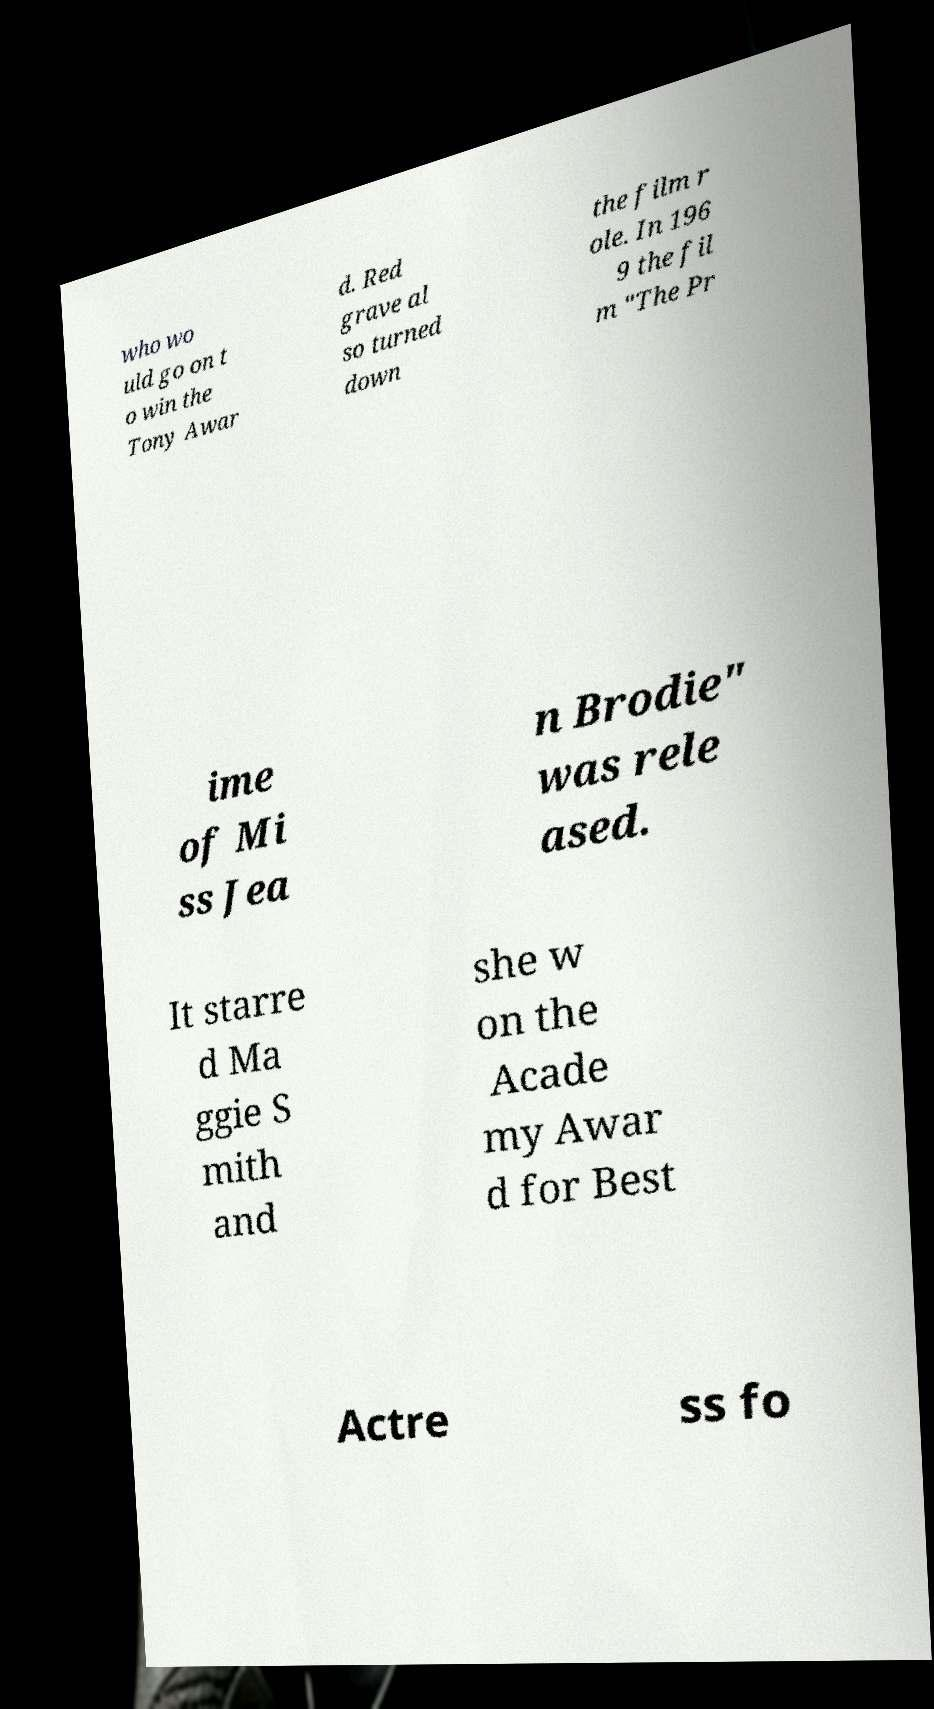Could you assist in decoding the text presented in this image and type it out clearly? who wo uld go on t o win the Tony Awar d. Red grave al so turned down the film r ole. In 196 9 the fil m "The Pr ime of Mi ss Jea n Brodie" was rele ased. It starre d Ma ggie S mith and she w on the Acade my Awar d for Best Actre ss fo 